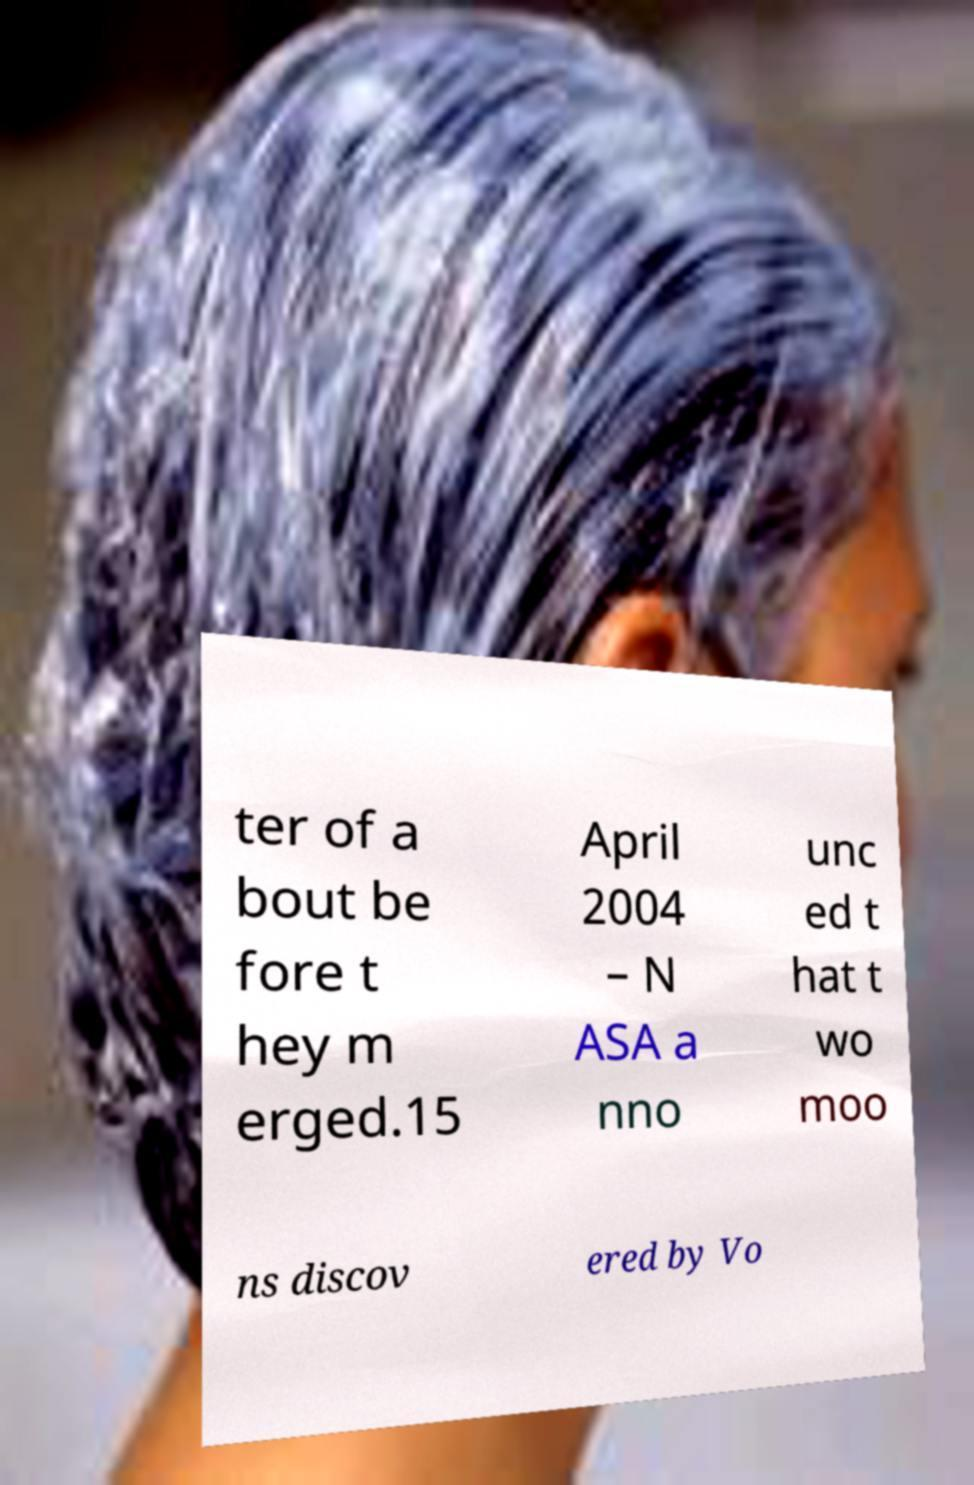For documentation purposes, I need the text within this image transcribed. Could you provide that? ter of a bout be fore t hey m erged.15 April 2004 – N ASA a nno unc ed t hat t wo moo ns discov ered by Vo 